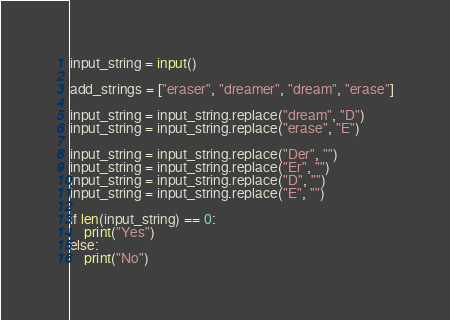Convert code to text. <code><loc_0><loc_0><loc_500><loc_500><_Python_>input_string = input()

add_strings = ["eraser", "dreamer", "dream", "erase"]

input_string = input_string.replace("dream", "D")
input_string = input_string.replace("erase", "E")

input_string = input_string.replace("Der", "")
input_string = input_string.replace("Er", "")
input_string = input_string.replace("D", "")
input_string = input_string.replace("E", "")

if len(input_string) == 0:
    print("Yes")
else:
    print("No")
</code> 